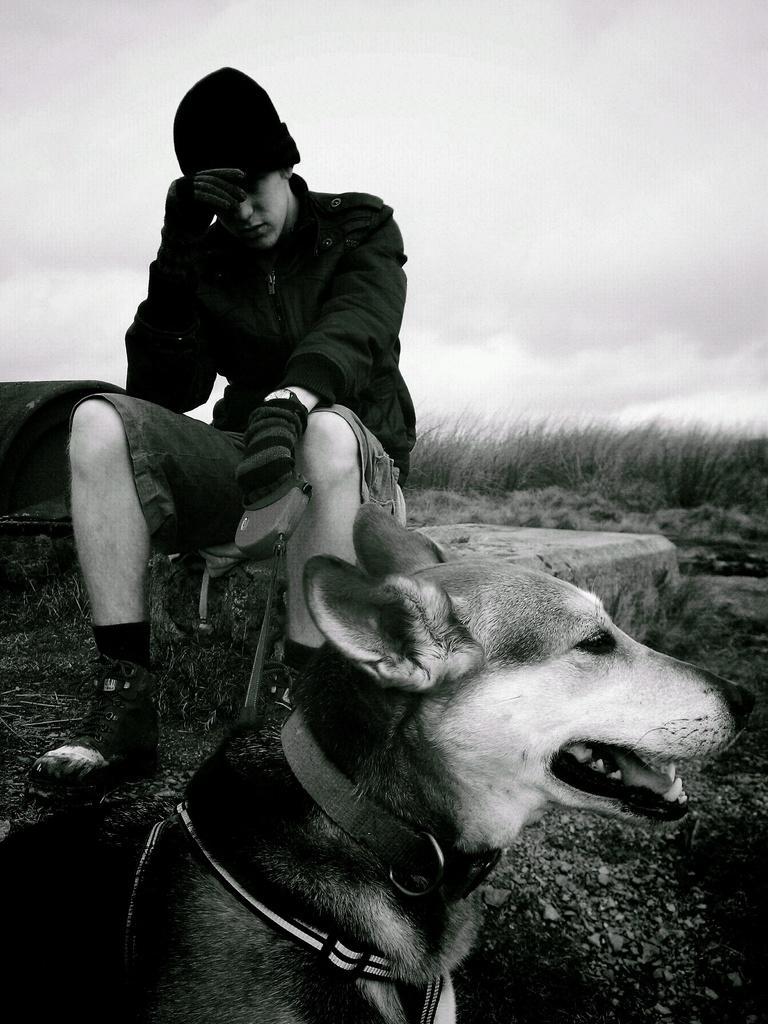Describe this image in one or two sentences. In this image in the center there is a dog which is in the front and in the background there is a man sitting and there are dry grass and the sky is cloudy. 